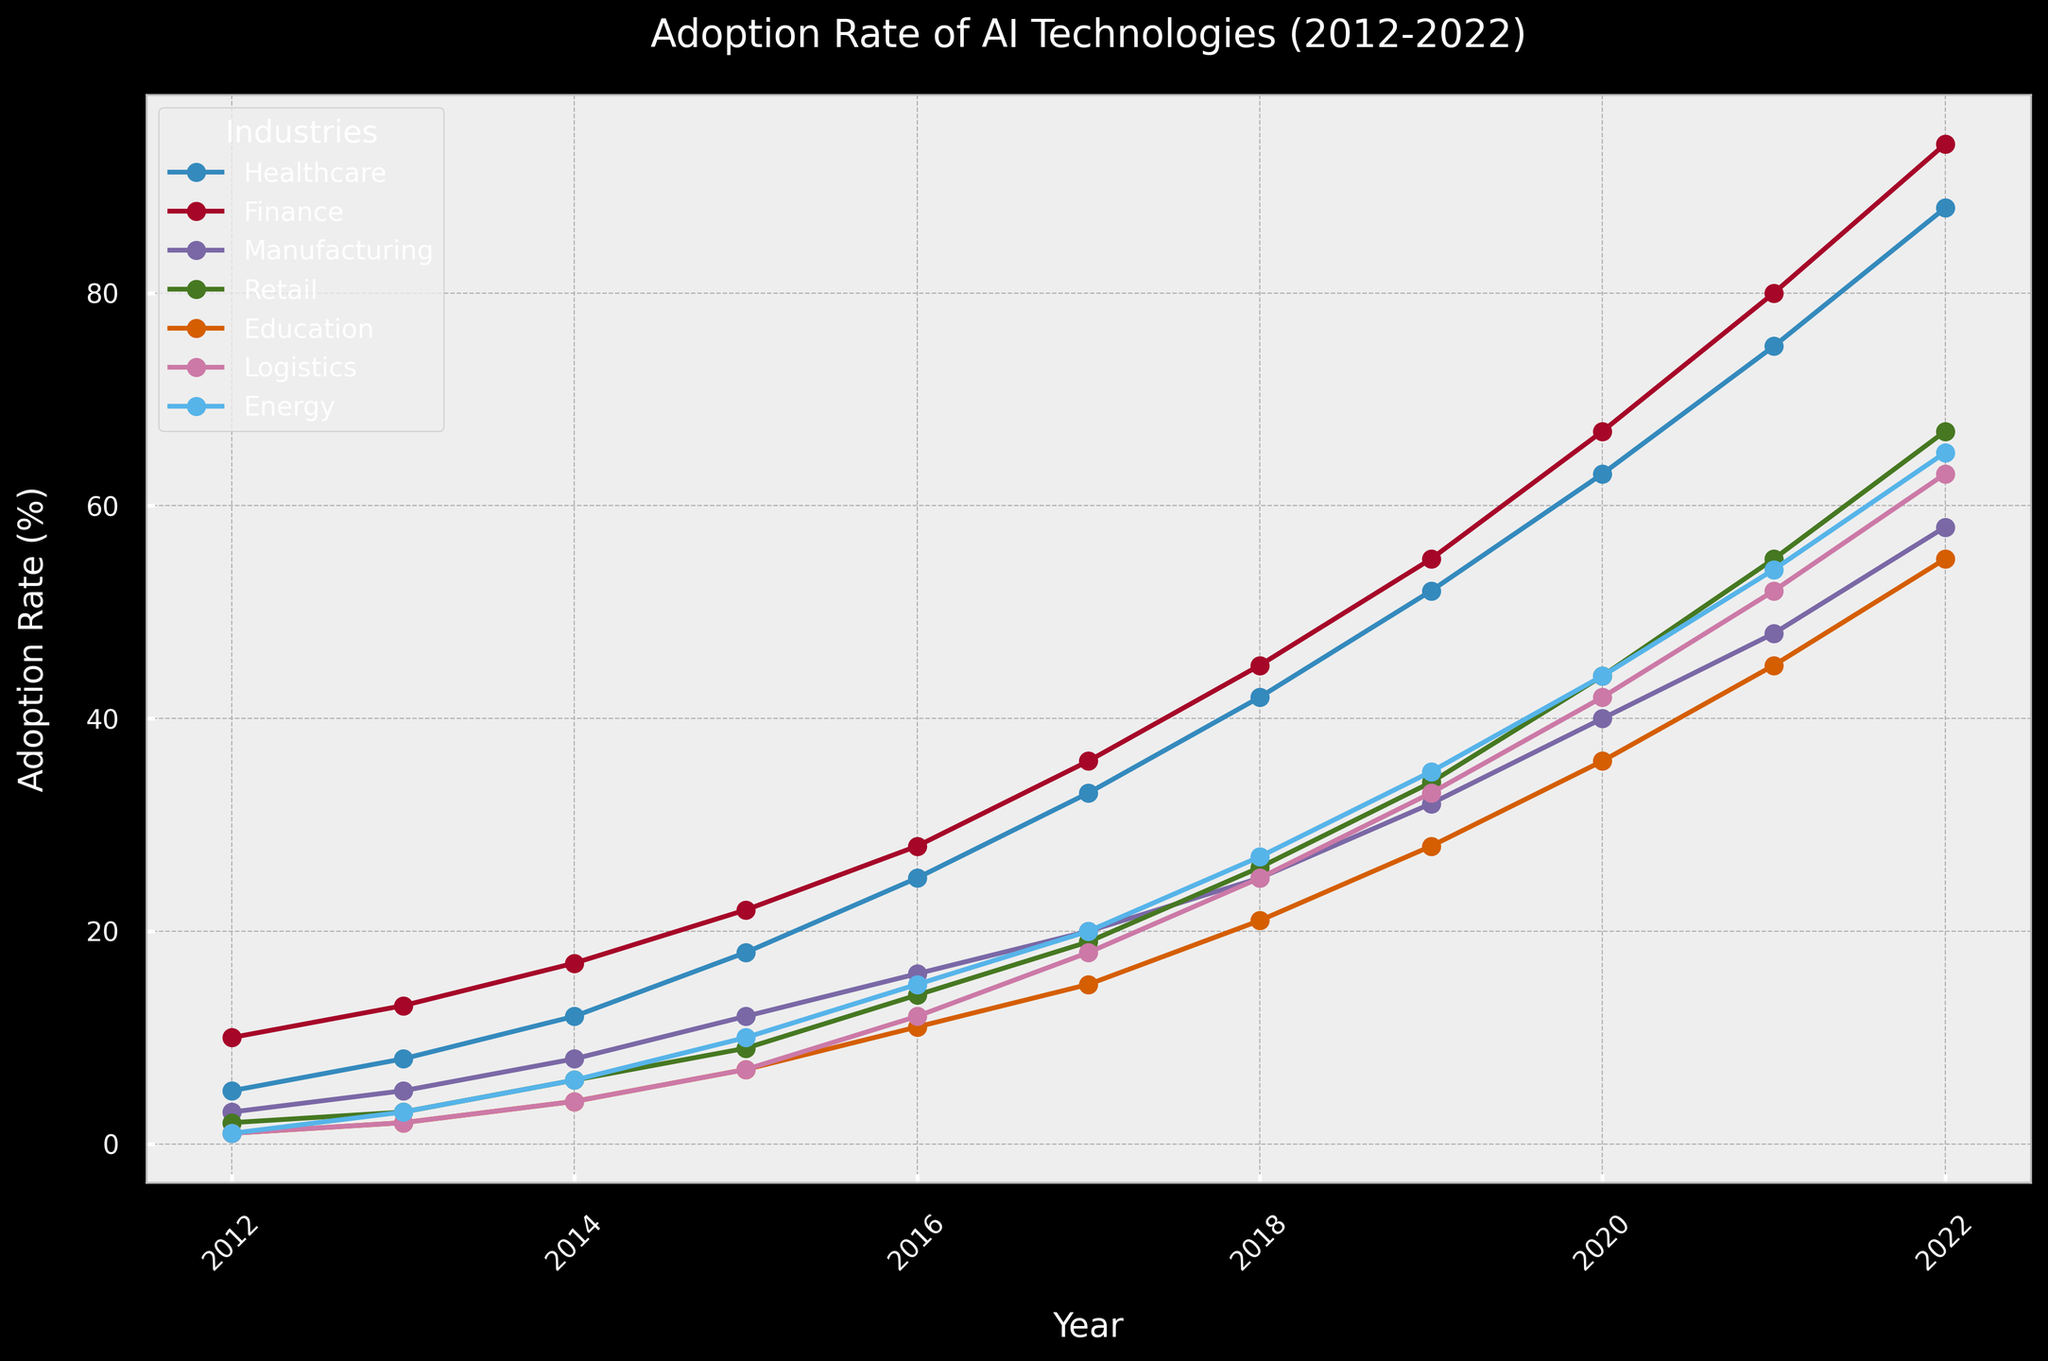Which industry had the highest adoption rate of AI technologies in 2022? Look at the endpoints of each line in 2022 and compare the values. Finance shows the highest value at 94%.
Answer: Finance Which two industries saw the closest adoption rates in 2018? In 2018, compare the adoption rates of each industry. Logistics (25%) and Retail (26%) have the closest adoption rates.
Answer: Logistics and Retail In what year did the adoption rate of AI in Healthcare first exceed 50%? Trace the line for Healthcare and look for the first year the rate goes above 50%. This happens in 2019 (52%).
Answer: 2019 Which industry had the slowest initial adoption rate of AI from 2012 to 2013? Compare the values from 2012 to 2013 for each industry. Both Education and Logistics went from 1% to 2%, but Retail increased from 2% to 3%, all three showing slow growth, but the smallest numerical increase comes from Education and Logistics.
Answer: Education and Logistics What's the average adoption rate of AI in the Energy sector over the decade? Sum the adoption rates from 2012 to 2022 and divide by the number of years: (1+3+6+10+15+20+27+35+44+54+65)/11 = 27.82
Answer: 27.82 Which industry experienced the largest growth in AI adoption between 2016 and 2020? Calculate the difference in adoption rates for each industry between 2016 and 2020. Healthcare: 63-25 = 38; Finance: 67-28 = 39; Manufacturing: 40-16 = 24; Retail: 44-14 = 30; Education: 36-11 = 25; Logistics: 42-12 = 30; Energy: 44-15 = 29. The Finance sector shows the largest increase of 39%.
Answer: Finance In which year did the Retail industry's AI adoption rate first surpass that of Manufacturing? Compare the values for Retail and Manufacturing each year. Retail first surpasses Manufacturing in 2020 (44% vs 40%).
Answer: 2020 What's the difference in AI adoption rate between Logistics and Education in 2022? Compare the final values for both industries in 2022. Logistics is at 63% and Education is at 55%, so the difference is 63 - 55 = 8.
Answer: 8 When did the adoption rate of AI in Retail surpass 50%? Trace the Retail line and identify when it first crosses 50%. This occurs in 2021 (55%).
Answer: 2021 What is the median adoption rate of AI for Finance from 2015-2022? List the values from 2015-2022: 22, 28, 36, 45, 55, 67, 80, 94. The median is the middle of the sorted list or the average of the two middle numbers if the list has an even number of values. Here, middle numbers are 45 and 55; therefore, the median is (45+55)/2 = 50.
Answer: 50 